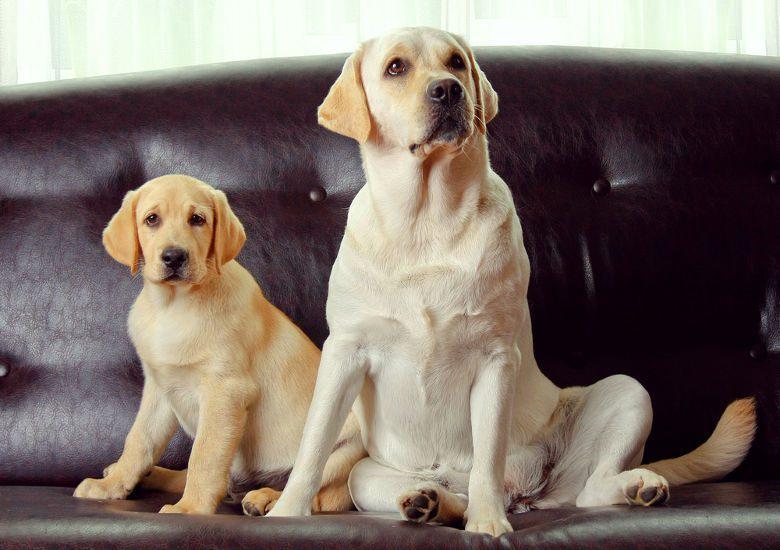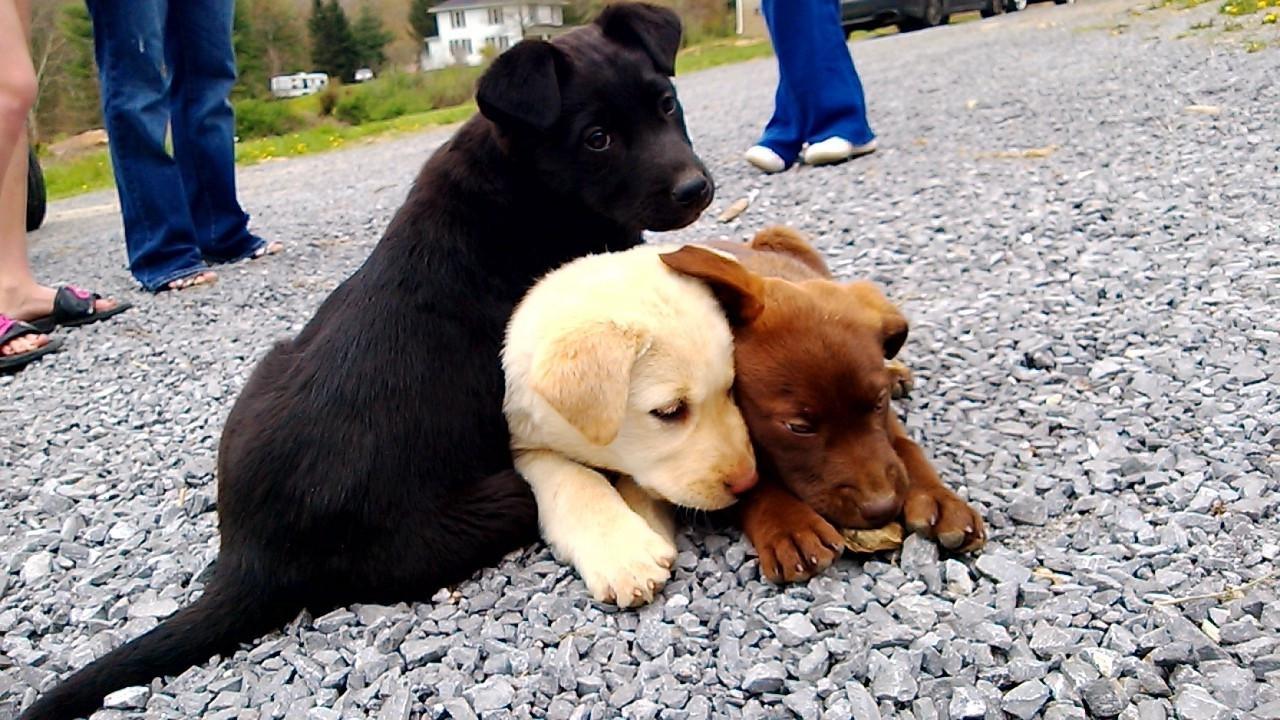The first image is the image on the left, the second image is the image on the right. Considering the images on both sides, is "Each image shows one forward-facing young dog, and the dogs in the left and right images have dark fur color." valid? Answer yes or no. No. The first image is the image on the left, the second image is the image on the right. Analyze the images presented: Is the assertion "there are two black puppies in the image pair" valid? Answer yes or no. No. 